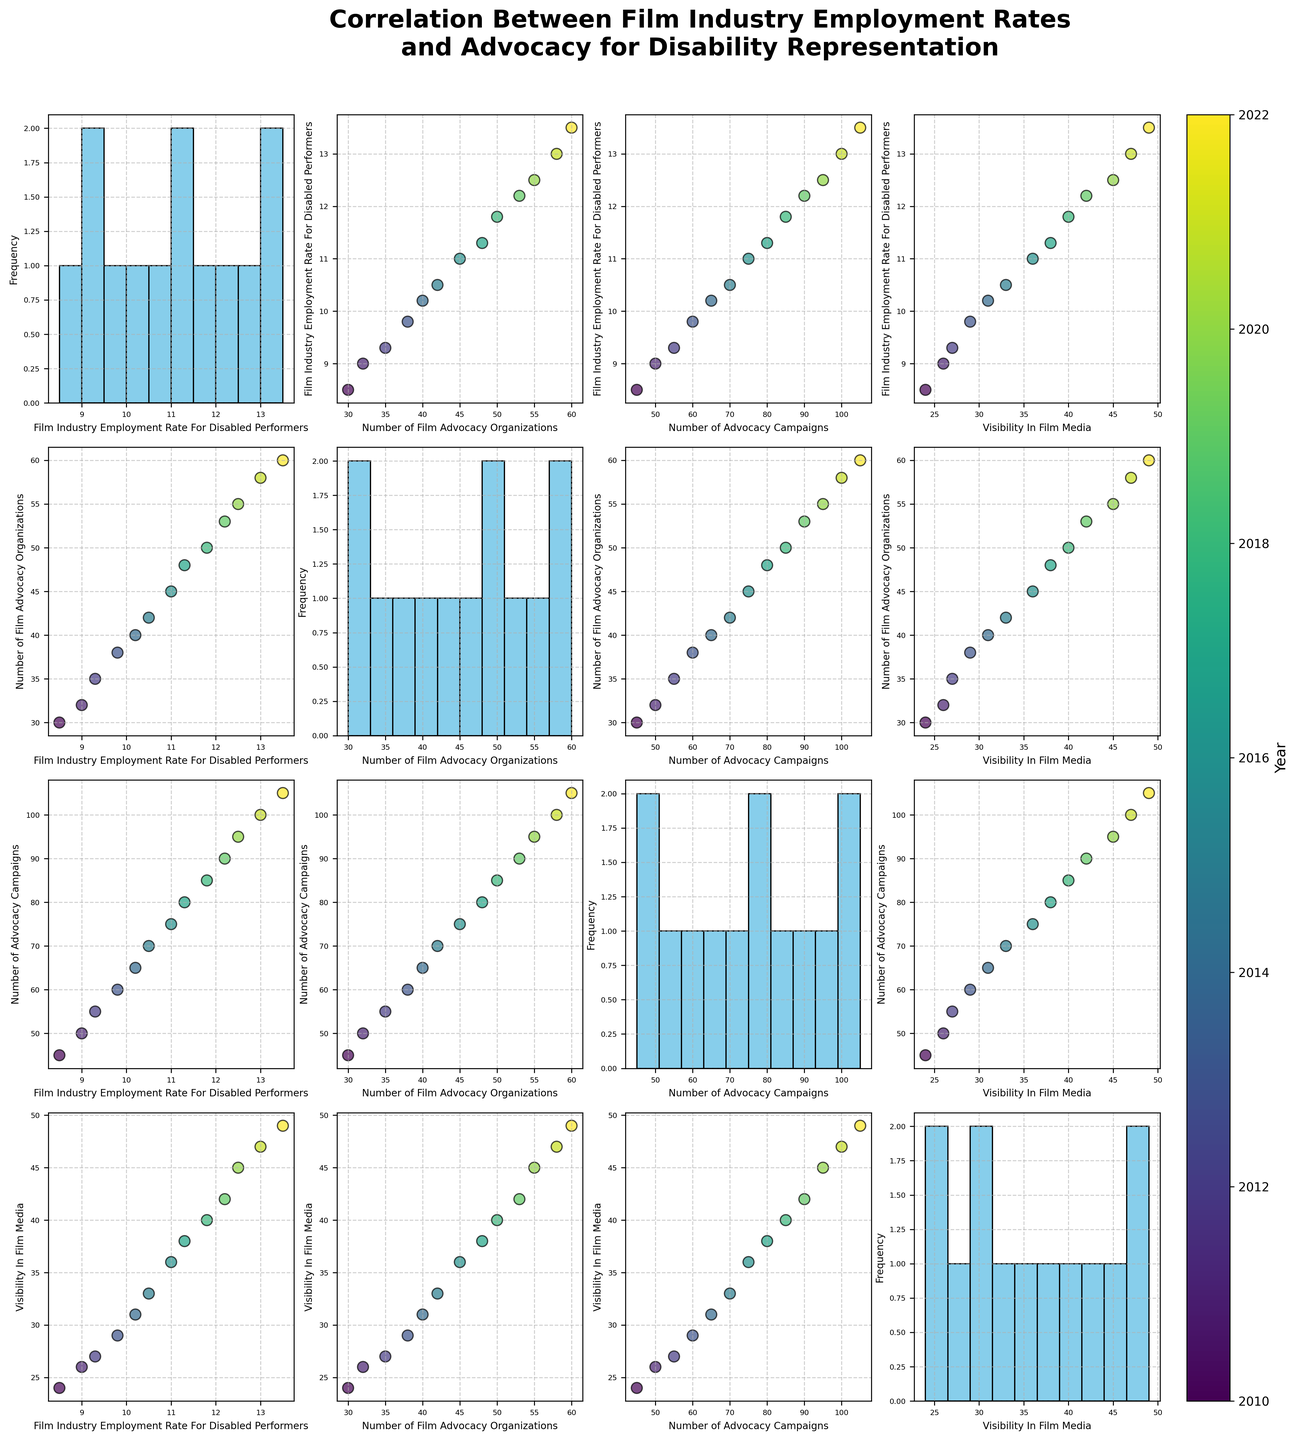Which axes depict the number of advocacy campaigns? The axes in the scatter plot matrix labeled 'Number of Advocacy Campaigns' represent this variable. It appears on both the x-axes and y-axes within the matrix.
Answer: Advocacy Campaigns axes What general trend can you observe between the number of advocacy organizations and the employment rate for disabled performers? There is a general upward trend observed between the 'Number of Film Advocacy Organizations' and the 'Film Industry Employment Rate For Disabled Performers'. This indicates that as the number of advocacy organizations increases, the employment rate for disabled performers also tends to increase.
Answer: Upward trend How is the similarity or difference of the distribution of visibility in film media and film industry employment rate displayed? The histogram on the diagonal line of the scatter plot matrix allows for comparisons of distributions. By observing the histograms for 'Visibility In Film Media' and 'Film Industry Employment Rate For Disabled Performers', one can see how each variable is distributed over the years. Both show a general increase over time, but the exact shapes of their distributions can be visually assessed.
Answer: Both show increasing distribution Is there a stronger correlation between the employment rate for disabled performers and the visibility in film media or the number of advocacy campaigns? By comparing the scatter plots, it can be inferred that the correlation between 'Film Industry Employment Rate For Disabled Performers' and 'Visibility In Film Media' appears slightly stronger with a more consistent upward trend compared to 'Number of Advocacy Campaigns'.
Answer: Stronger with Visibility In Film Media How does the employment rate for disabled performers change over time? By examining the scatter plots that use 'Year' as a color gradient, the employment rate for disabled performers generally goes from lower values in earlier years to higher values in later years. This is represented by the color transition from yellow to dark blue.
Answer: It increases over time What patterns can be observed in the scatter plots involving the number of advocacy campaigns? Scatter plots involving 'Number of Advocacy Campaigns' generally show a positive correlation with 'Film Industry Employment Rate For Disabled Performers', 'Number of Film Advocacy Organizations', and 'Visibility In Film Media'. This indicates as the number of advocacy campaigns increases, the other variables also tend to increase.
Answer: Positive correlations What can be inferred about the growth of advocacy organizations over time? The scatter plots showing 'Year' with 'Number of Film Advocacy Organizations' indicate a steady increase over time. The points transition from colors representing earlier years to colors representing later years, consistently moving upwards.
Answer: Steady increase Which pairs of variables show the strongest visual correlation? The pairs 'Film Industry Employment Rate For Disabled Performers' and 'Visibility In Film Media' show strong visual correlation, as do 'Number of Advocacy Campaigns' and 'Visibility In Film Media'. Both pairs demonstrate a clear upward trend in their scatter plots.
Answer: Employment-Visibility and Campaigns-Visibility 